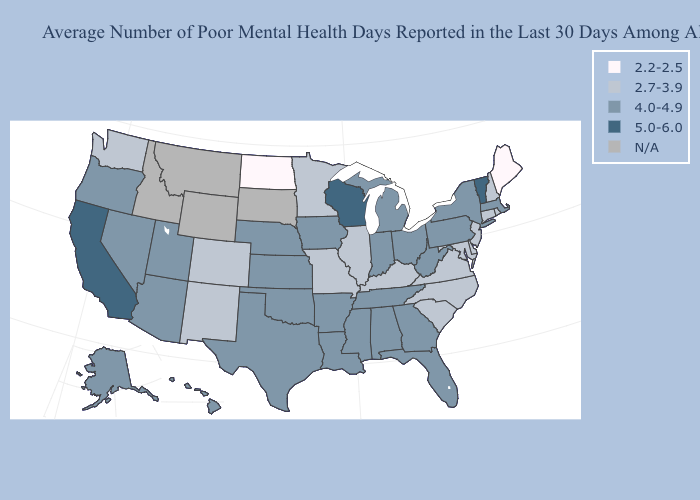Name the states that have a value in the range 2.7-3.9?
Short answer required. Colorado, Connecticut, Delaware, Illinois, Kentucky, Maryland, Minnesota, Missouri, New Hampshire, New Jersey, New Mexico, North Carolina, Rhode Island, South Carolina, Virginia, Washington. Among the states that border Alabama , which have the highest value?
Short answer required. Florida, Georgia, Mississippi, Tennessee. What is the highest value in the Northeast ?
Quick response, please. 5.0-6.0. What is the value of Texas?
Keep it brief. 4.0-4.9. What is the value of Montana?
Give a very brief answer. N/A. What is the value of New Jersey?
Keep it brief. 2.7-3.9. Does the first symbol in the legend represent the smallest category?
Be succinct. Yes. What is the lowest value in states that border New Mexico?
Short answer required. 2.7-3.9. What is the highest value in the West ?
Be succinct. 5.0-6.0. What is the lowest value in states that border Tennessee?
Answer briefly. 2.7-3.9. Among the states that border Minnesota , does North Dakota have the highest value?
Concise answer only. No. Name the states that have a value in the range 2.7-3.9?
Keep it brief. Colorado, Connecticut, Delaware, Illinois, Kentucky, Maryland, Minnesota, Missouri, New Hampshire, New Jersey, New Mexico, North Carolina, Rhode Island, South Carolina, Virginia, Washington. What is the value of Vermont?
Concise answer only. 5.0-6.0. 